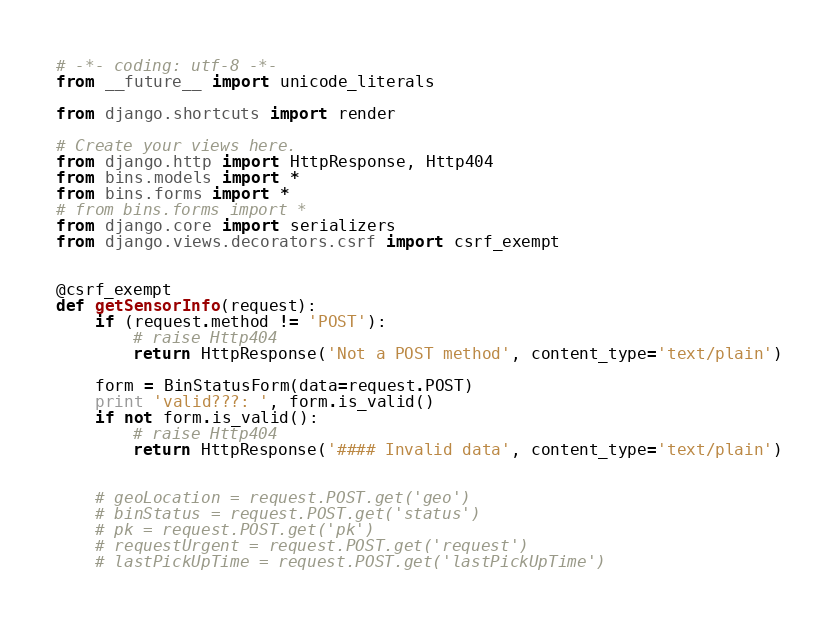Convert code to text. <code><loc_0><loc_0><loc_500><loc_500><_Python_># -*- coding: utf-8 -*-
from __future__ import unicode_literals

from django.shortcuts import render

# Create your views here.
from django.http import HttpResponse, Http404
from bins.models import *
from bins.forms import *
# from bins.forms import *
from django.core import serializers
from django.views.decorators.csrf import csrf_exempt


@csrf_exempt
def getSensorInfo(request):
    if (request.method != 'POST'):
        # raise Http404
        return HttpResponse('Not a POST method', content_type='text/plain')

    form = BinStatusForm(data=request.POST)
    print 'valid???: ', form.is_valid()
    if not form.is_valid():
        # raise Http404
        return HttpResponse('#### Invalid data', content_type='text/plain')


    # geoLocation = request.POST.get('geo')
    # binStatus = request.POST.get('status')
    # pk = request.POST.get('pk')
    # requestUrgent = request.POST.get('request')
    # lastPickUpTime = request.POST.get('lastPickUpTime')
</code> 